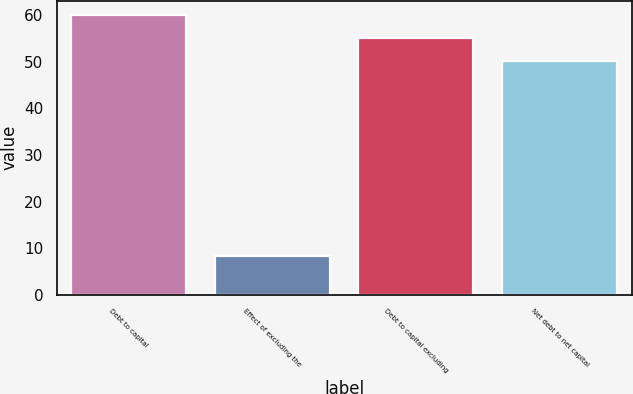<chart> <loc_0><loc_0><loc_500><loc_500><bar_chart><fcel>Debt to capital<fcel>Effect of excluding the<fcel>Debt to capital excluding<fcel>Net debt to net capital<nl><fcel>60.14<fcel>8.3<fcel>55.12<fcel>50.1<nl></chart> 